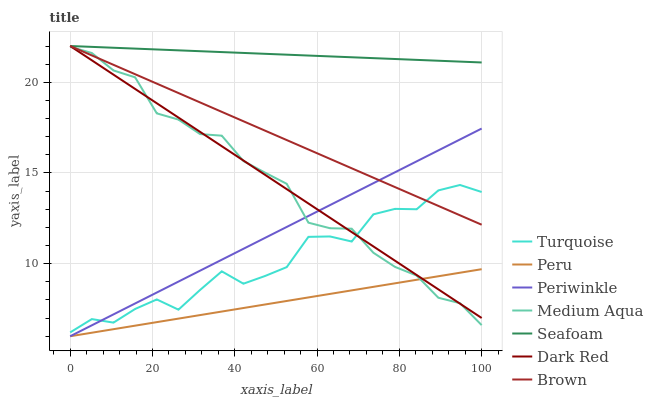Does Peru have the minimum area under the curve?
Answer yes or no. Yes. Does Seafoam have the maximum area under the curve?
Answer yes or no. Yes. Does Turquoise have the minimum area under the curve?
Answer yes or no. No. Does Turquoise have the maximum area under the curve?
Answer yes or no. No. Is Brown the smoothest?
Answer yes or no. Yes. Is Turquoise the roughest?
Answer yes or no. Yes. Is Dark Red the smoothest?
Answer yes or no. No. Is Dark Red the roughest?
Answer yes or no. No. Does Turquoise have the lowest value?
Answer yes or no. No. Does Turquoise have the highest value?
Answer yes or no. No. Is Peru less than Turquoise?
Answer yes or no. Yes. Is Seafoam greater than Peru?
Answer yes or no. Yes. Does Peru intersect Turquoise?
Answer yes or no. No. 